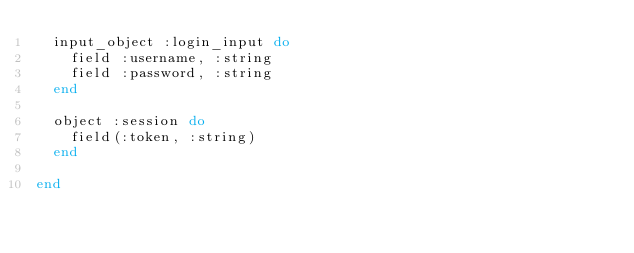<code> <loc_0><loc_0><loc_500><loc_500><_Elixir_>  input_object :login_input do
    field :username, :string
    field :password, :string
  end

  object :session do
    field(:token, :string)
  end

end
</code> 